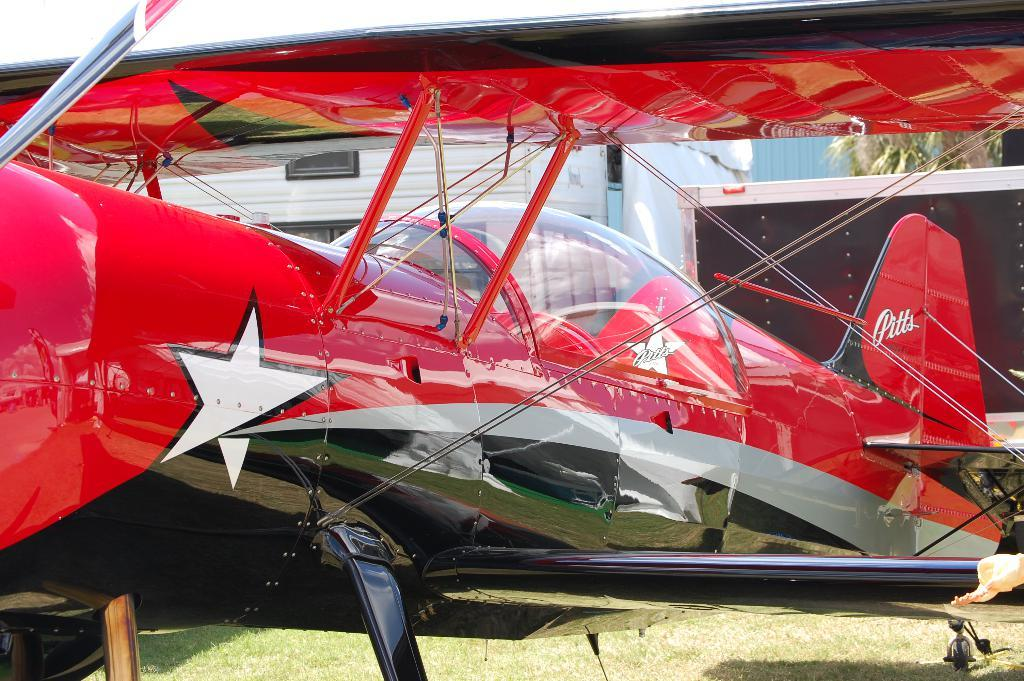What is the main subject of the image? There is a biplane in the center of the image. What is visible at the bottom of the image? There is grass at the bottom of the image. What type of fuel is being used by the hand in the image? There is no hand present in the image, and therefore no fuel usage can be observed. 